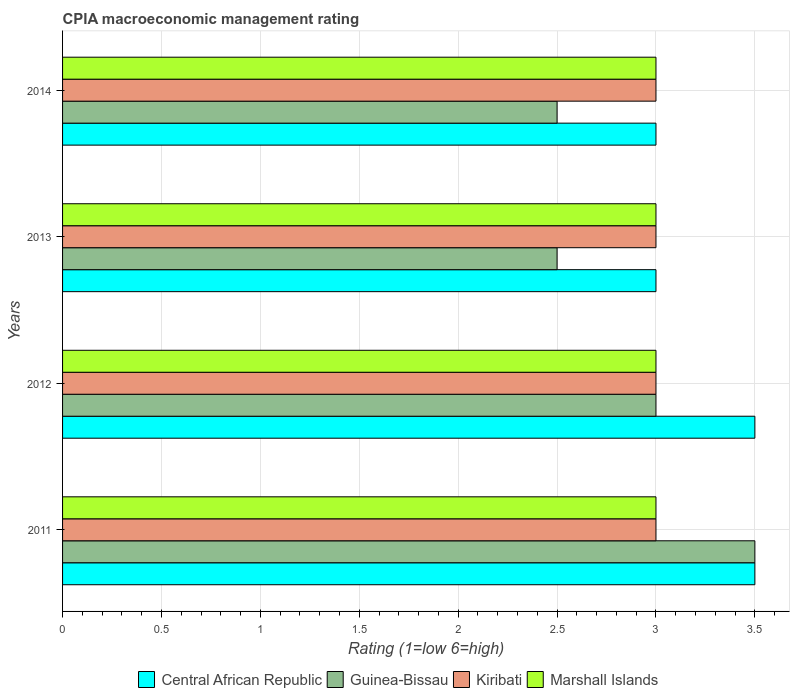How many groups of bars are there?
Your answer should be compact. 4. Are the number of bars per tick equal to the number of legend labels?
Your answer should be very brief. Yes. How many bars are there on the 3rd tick from the top?
Give a very brief answer. 4. How many bars are there on the 2nd tick from the bottom?
Offer a very short reply. 4. What is the label of the 1st group of bars from the top?
Your answer should be compact. 2014. In which year was the CPIA rating in Marshall Islands minimum?
Your answer should be very brief. 2011. What is the difference between the CPIA rating in Marshall Islands in 2011 and that in 2013?
Ensure brevity in your answer.  0. What is the difference between the CPIA rating in Guinea-Bissau in 2013 and the CPIA rating in Central African Republic in 2012?
Your answer should be compact. -1. In the year 2011, what is the difference between the CPIA rating in Guinea-Bissau and CPIA rating in Kiribati?
Your answer should be compact. 0.5. In how many years, is the CPIA rating in Central African Republic greater than 2.7 ?
Ensure brevity in your answer.  4. What is the difference between the highest and the lowest CPIA rating in Guinea-Bissau?
Provide a succinct answer. 1. What does the 1st bar from the top in 2012 represents?
Keep it short and to the point. Marshall Islands. What does the 2nd bar from the bottom in 2014 represents?
Provide a short and direct response. Guinea-Bissau. How many bars are there?
Ensure brevity in your answer.  16. Are all the bars in the graph horizontal?
Give a very brief answer. Yes. What is the difference between two consecutive major ticks on the X-axis?
Ensure brevity in your answer.  0.5. Are the values on the major ticks of X-axis written in scientific E-notation?
Ensure brevity in your answer.  No. Does the graph contain any zero values?
Make the answer very short. No. Does the graph contain grids?
Your answer should be very brief. Yes. Where does the legend appear in the graph?
Keep it short and to the point. Bottom center. What is the title of the graph?
Provide a short and direct response. CPIA macroeconomic management rating. Does "Mexico" appear as one of the legend labels in the graph?
Your answer should be very brief. No. What is the label or title of the Y-axis?
Give a very brief answer. Years. What is the Rating (1=low 6=high) in Central African Republic in 2011?
Provide a succinct answer. 3.5. What is the Rating (1=low 6=high) of Marshall Islands in 2011?
Make the answer very short. 3. What is the Rating (1=low 6=high) in Central African Republic in 2012?
Keep it short and to the point. 3.5. What is the Rating (1=low 6=high) in Marshall Islands in 2012?
Ensure brevity in your answer.  3. What is the Rating (1=low 6=high) of Central African Republic in 2013?
Your answer should be compact. 3. What is the Rating (1=low 6=high) of Marshall Islands in 2013?
Your answer should be compact. 3. What is the Rating (1=low 6=high) of Guinea-Bissau in 2014?
Your answer should be compact. 2.5. What is the Rating (1=low 6=high) in Kiribati in 2014?
Your response must be concise. 3. Across all years, what is the maximum Rating (1=low 6=high) in Central African Republic?
Offer a very short reply. 3.5. Across all years, what is the maximum Rating (1=low 6=high) in Guinea-Bissau?
Make the answer very short. 3.5. Across all years, what is the maximum Rating (1=low 6=high) in Kiribati?
Ensure brevity in your answer.  3. Across all years, what is the maximum Rating (1=low 6=high) in Marshall Islands?
Your response must be concise. 3. Across all years, what is the minimum Rating (1=low 6=high) of Central African Republic?
Offer a terse response. 3. Across all years, what is the minimum Rating (1=low 6=high) of Guinea-Bissau?
Your response must be concise. 2.5. Across all years, what is the minimum Rating (1=low 6=high) in Kiribati?
Keep it short and to the point. 3. Across all years, what is the minimum Rating (1=low 6=high) in Marshall Islands?
Give a very brief answer. 3. What is the total Rating (1=low 6=high) of Guinea-Bissau in the graph?
Give a very brief answer. 11.5. What is the total Rating (1=low 6=high) of Kiribati in the graph?
Ensure brevity in your answer.  12. What is the difference between the Rating (1=low 6=high) in Central African Republic in 2011 and that in 2012?
Your answer should be very brief. 0. What is the difference between the Rating (1=low 6=high) of Kiribati in 2011 and that in 2012?
Offer a very short reply. 0. What is the difference between the Rating (1=low 6=high) in Kiribati in 2011 and that in 2013?
Offer a terse response. 0. What is the difference between the Rating (1=low 6=high) of Marshall Islands in 2011 and that in 2013?
Ensure brevity in your answer.  0. What is the difference between the Rating (1=low 6=high) of Kiribati in 2011 and that in 2014?
Give a very brief answer. 0. What is the difference between the Rating (1=low 6=high) in Guinea-Bissau in 2012 and that in 2013?
Offer a very short reply. 0.5. What is the difference between the Rating (1=low 6=high) in Kiribati in 2012 and that in 2013?
Provide a short and direct response. 0. What is the difference between the Rating (1=low 6=high) of Central African Republic in 2012 and that in 2014?
Your answer should be compact. 0.5. What is the difference between the Rating (1=low 6=high) in Guinea-Bissau in 2012 and that in 2014?
Keep it short and to the point. 0.5. What is the difference between the Rating (1=low 6=high) of Marshall Islands in 2012 and that in 2014?
Provide a short and direct response. 0. What is the difference between the Rating (1=low 6=high) of Central African Republic in 2013 and that in 2014?
Offer a terse response. 0. What is the difference between the Rating (1=low 6=high) in Guinea-Bissau in 2013 and that in 2014?
Provide a succinct answer. 0. What is the difference between the Rating (1=low 6=high) of Kiribati in 2013 and that in 2014?
Give a very brief answer. 0. What is the difference between the Rating (1=low 6=high) in Central African Republic in 2011 and the Rating (1=low 6=high) in Guinea-Bissau in 2012?
Make the answer very short. 0.5. What is the difference between the Rating (1=low 6=high) in Central African Republic in 2011 and the Rating (1=low 6=high) in Kiribati in 2012?
Offer a very short reply. 0.5. What is the difference between the Rating (1=low 6=high) of Guinea-Bissau in 2011 and the Rating (1=low 6=high) of Kiribati in 2012?
Ensure brevity in your answer.  0.5. What is the difference between the Rating (1=low 6=high) of Guinea-Bissau in 2011 and the Rating (1=low 6=high) of Marshall Islands in 2012?
Provide a succinct answer. 0.5. What is the difference between the Rating (1=low 6=high) of Kiribati in 2011 and the Rating (1=low 6=high) of Marshall Islands in 2012?
Your response must be concise. 0. What is the difference between the Rating (1=low 6=high) of Central African Republic in 2011 and the Rating (1=low 6=high) of Guinea-Bissau in 2013?
Your answer should be compact. 1. What is the difference between the Rating (1=low 6=high) in Guinea-Bissau in 2011 and the Rating (1=low 6=high) in Marshall Islands in 2013?
Your response must be concise. 0.5. What is the difference between the Rating (1=low 6=high) in Kiribati in 2011 and the Rating (1=low 6=high) in Marshall Islands in 2013?
Provide a short and direct response. 0. What is the difference between the Rating (1=low 6=high) of Central African Republic in 2011 and the Rating (1=low 6=high) of Guinea-Bissau in 2014?
Your answer should be compact. 1. What is the difference between the Rating (1=low 6=high) of Central African Republic in 2011 and the Rating (1=low 6=high) of Marshall Islands in 2014?
Your answer should be very brief. 0.5. What is the difference between the Rating (1=low 6=high) in Guinea-Bissau in 2011 and the Rating (1=low 6=high) in Marshall Islands in 2014?
Offer a terse response. 0.5. What is the difference between the Rating (1=low 6=high) in Guinea-Bissau in 2012 and the Rating (1=low 6=high) in Kiribati in 2013?
Your response must be concise. 0. What is the difference between the Rating (1=low 6=high) in Guinea-Bissau in 2012 and the Rating (1=low 6=high) in Marshall Islands in 2013?
Give a very brief answer. 0. What is the difference between the Rating (1=low 6=high) of Central African Republic in 2012 and the Rating (1=low 6=high) of Guinea-Bissau in 2014?
Ensure brevity in your answer.  1. What is the difference between the Rating (1=low 6=high) in Central African Republic in 2012 and the Rating (1=low 6=high) in Kiribati in 2014?
Keep it short and to the point. 0.5. What is the difference between the Rating (1=low 6=high) in Guinea-Bissau in 2012 and the Rating (1=low 6=high) in Marshall Islands in 2014?
Offer a very short reply. 0. What is the difference between the Rating (1=low 6=high) of Central African Republic in 2013 and the Rating (1=low 6=high) of Guinea-Bissau in 2014?
Offer a very short reply. 0.5. What is the difference between the Rating (1=low 6=high) of Guinea-Bissau in 2013 and the Rating (1=low 6=high) of Kiribati in 2014?
Offer a terse response. -0.5. What is the difference between the Rating (1=low 6=high) in Guinea-Bissau in 2013 and the Rating (1=low 6=high) in Marshall Islands in 2014?
Your answer should be very brief. -0.5. What is the average Rating (1=low 6=high) of Guinea-Bissau per year?
Provide a short and direct response. 2.88. What is the average Rating (1=low 6=high) in Marshall Islands per year?
Your response must be concise. 3. In the year 2011, what is the difference between the Rating (1=low 6=high) in Central African Republic and Rating (1=low 6=high) in Kiribati?
Your response must be concise. 0.5. In the year 2011, what is the difference between the Rating (1=low 6=high) in Central African Republic and Rating (1=low 6=high) in Marshall Islands?
Your answer should be compact. 0.5. In the year 2011, what is the difference between the Rating (1=low 6=high) in Guinea-Bissau and Rating (1=low 6=high) in Kiribati?
Your response must be concise. 0.5. In the year 2011, what is the difference between the Rating (1=low 6=high) in Guinea-Bissau and Rating (1=low 6=high) in Marshall Islands?
Provide a succinct answer. 0.5. In the year 2012, what is the difference between the Rating (1=low 6=high) in Central African Republic and Rating (1=low 6=high) in Marshall Islands?
Your answer should be very brief. 0.5. In the year 2012, what is the difference between the Rating (1=low 6=high) in Kiribati and Rating (1=low 6=high) in Marshall Islands?
Provide a succinct answer. 0. In the year 2013, what is the difference between the Rating (1=low 6=high) in Central African Republic and Rating (1=low 6=high) in Kiribati?
Your answer should be compact. 0. In the year 2013, what is the difference between the Rating (1=low 6=high) of Central African Republic and Rating (1=low 6=high) of Marshall Islands?
Provide a succinct answer. 0. In the year 2013, what is the difference between the Rating (1=low 6=high) in Guinea-Bissau and Rating (1=low 6=high) in Marshall Islands?
Your response must be concise. -0.5. In the year 2014, what is the difference between the Rating (1=low 6=high) of Central African Republic and Rating (1=low 6=high) of Guinea-Bissau?
Offer a terse response. 0.5. In the year 2014, what is the difference between the Rating (1=low 6=high) of Central African Republic and Rating (1=low 6=high) of Marshall Islands?
Keep it short and to the point. 0. In the year 2014, what is the difference between the Rating (1=low 6=high) in Guinea-Bissau and Rating (1=low 6=high) in Kiribati?
Provide a short and direct response. -0.5. In the year 2014, what is the difference between the Rating (1=low 6=high) in Kiribati and Rating (1=low 6=high) in Marshall Islands?
Give a very brief answer. 0. What is the ratio of the Rating (1=low 6=high) of Kiribati in 2011 to that in 2012?
Make the answer very short. 1. What is the ratio of the Rating (1=low 6=high) in Marshall Islands in 2011 to that in 2012?
Your answer should be very brief. 1. What is the ratio of the Rating (1=low 6=high) in Marshall Islands in 2011 to that in 2013?
Offer a very short reply. 1. What is the ratio of the Rating (1=low 6=high) in Guinea-Bissau in 2011 to that in 2014?
Your answer should be very brief. 1.4. What is the ratio of the Rating (1=low 6=high) in Central African Republic in 2012 to that in 2013?
Provide a succinct answer. 1.17. What is the ratio of the Rating (1=low 6=high) of Guinea-Bissau in 2012 to that in 2013?
Provide a succinct answer. 1.2. What is the ratio of the Rating (1=low 6=high) in Marshall Islands in 2012 to that in 2013?
Provide a short and direct response. 1. What is the ratio of the Rating (1=low 6=high) in Central African Republic in 2012 to that in 2014?
Give a very brief answer. 1.17. What is the ratio of the Rating (1=low 6=high) of Guinea-Bissau in 2012 to that in 2014?
Ensure brevity in your answer.  1.2. What is the ratio of the Rating (1=low 6=high) of Marshall Islands in 2012 to that in 2014?
Make the answer very short. 1. What is the ratio of the Rating (1=low 6=high) in Central African Republic in 2013 to that in 2014?
Provide a succinct answer. 1. What is the ratio of the Rating (1=low 6=high) of Marshall Islands in 2013 to that in 2014?
Offer a very short reply. 1. What is the difference between the highest and the second highest Rating (1=low 6=high) of Central African Republic?
Offer a terse response. 0. What is the difference between the highest and the lowest Rating (1=low 6=high) of Central African Republic?
Keep it short and to the point. 0.5. What is the difference between the highest and the lowest Rating (1=low 6=high) of Guinea-Bissau?
Provide a succinct answer. 1. 